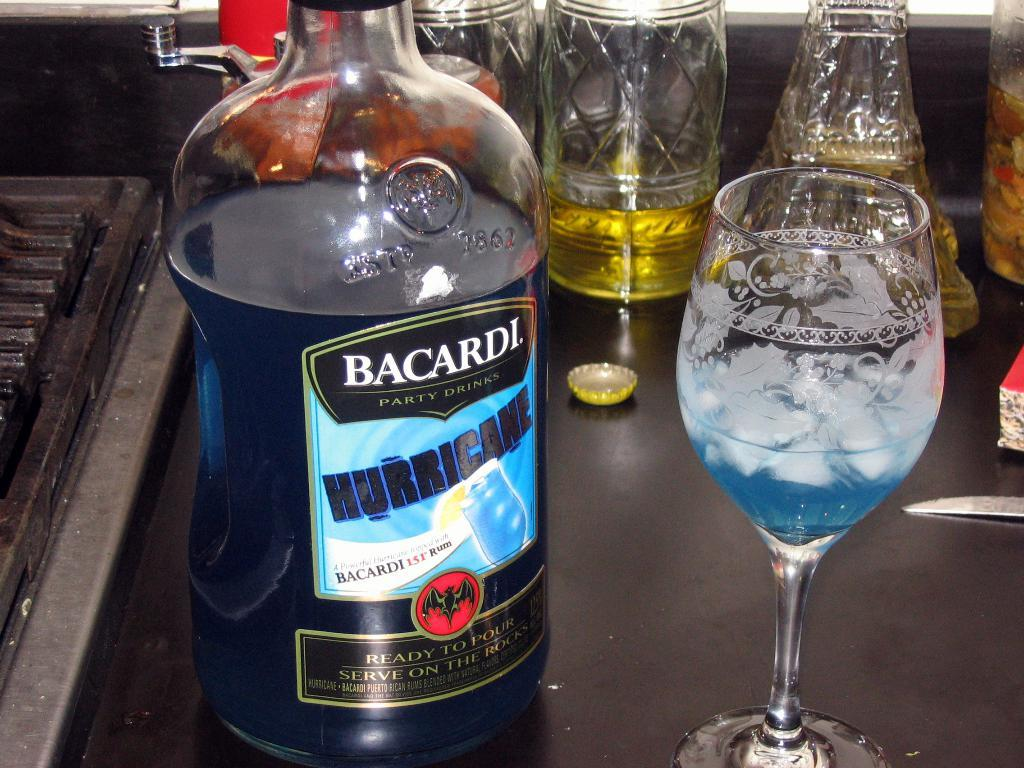What is one of the objects visible in the image? There is a bottle in the image. What else can be seen in the image? There are glasses in the image. What type of fire can be seen burning in the image? There is no fire present in the image; it only features a bottle and glasses. How many beds are visible in the image? There are no beds present in the image. 